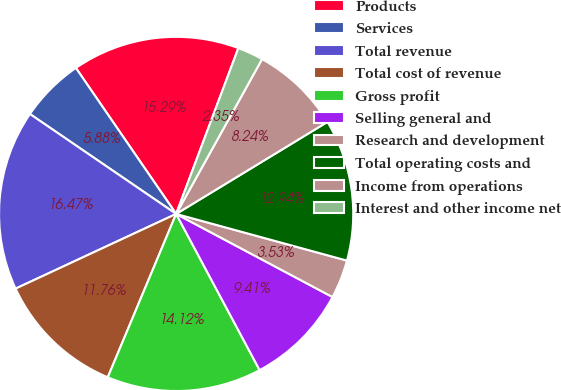Convert chart. <chart><loc_0><loc_0><loc_500><loc_500><pie_chart><fcel>Products<fcel>Services<fcel>Total revenue<fcel>Total cost of revenue<fcel>Gross profit<fcel>Selling general and<fcel>Research and development<fcel>Total operating costs and<fcel>Income from operations<fcel>Interest and other income net<nl><fcel>15.29%<fcel>5.88%<fcel>16.47%<fcel>11.76%<fcel>14.12%<fcel>9.41%<fcel>3.53%<fcel>12.94%<fcel>8.24%<fcel>2.35%<nl></chart> 